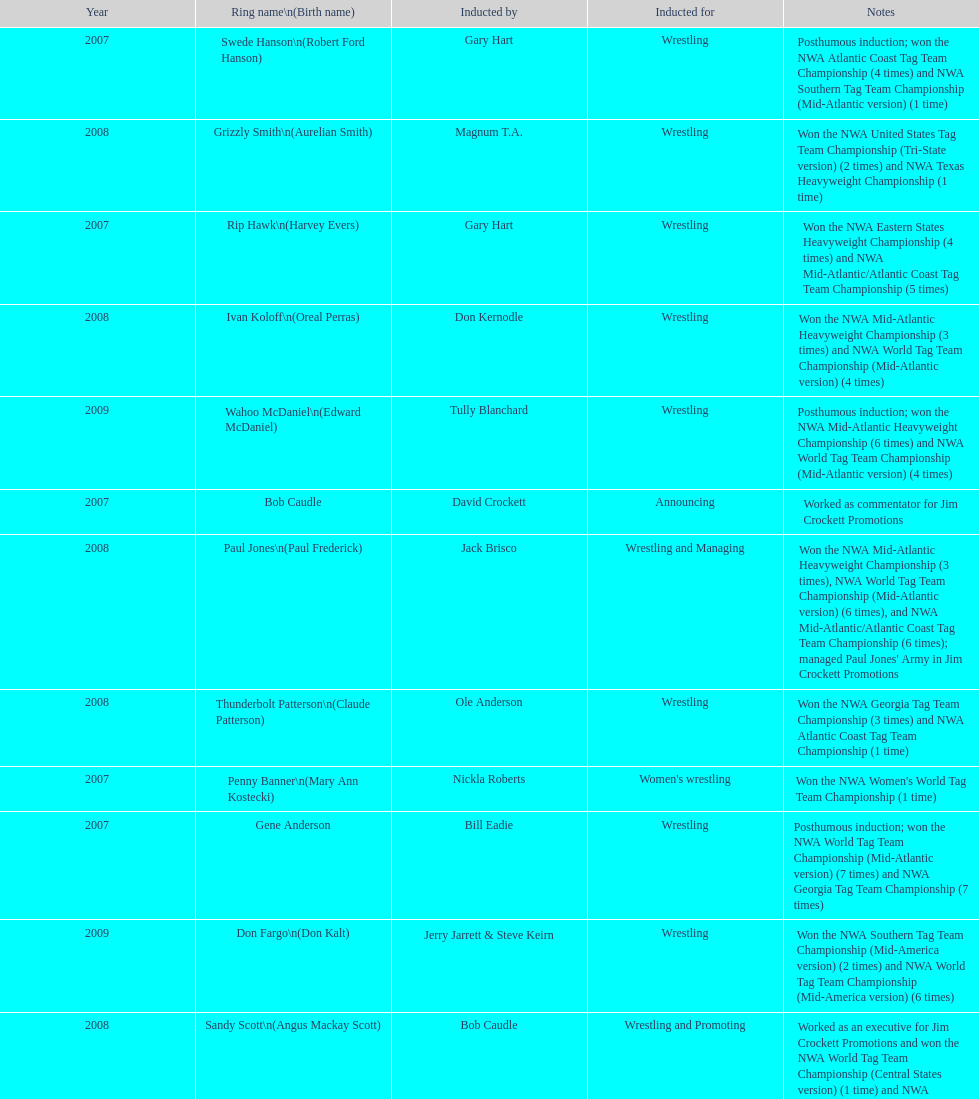Who has the actual name dale hey, grizzly smith, or buddy roberts? Buddy Roberts. 